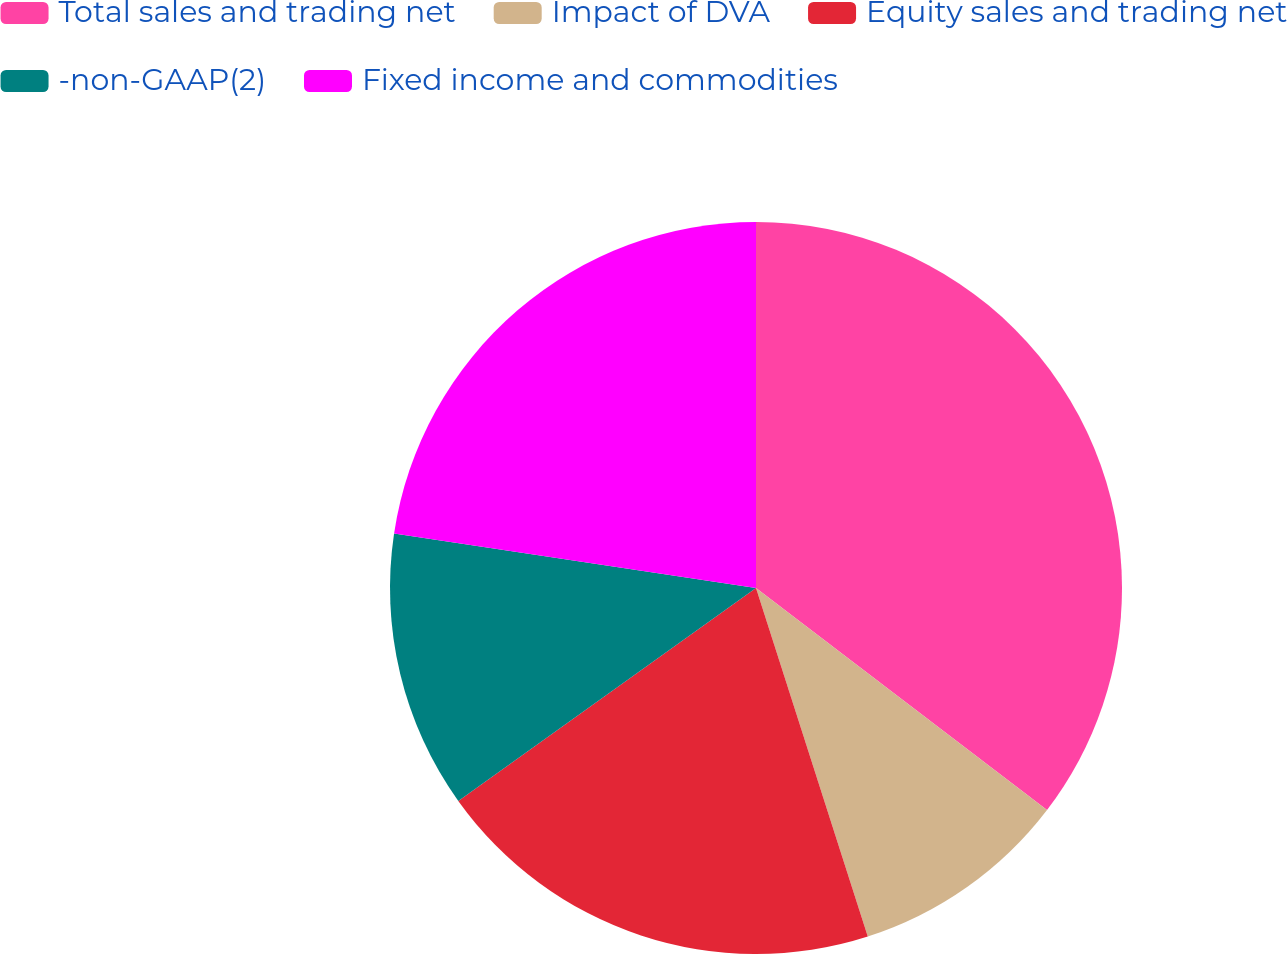Convert chart. <chart><loc_0><loc_0><loc_500><loc_500><pie_chart><fcel>Total sales and trading net<fcel>Impact of DVA<fcel>Equity sales and trading net<fcel>-non-GAAP(2)<fcel>Fixed income and commodities<nl><fcel>35.37%<fcel>9.69%<fcel>20.06%<fcel>12.26%<fcel>22.62%<nl></chart> 